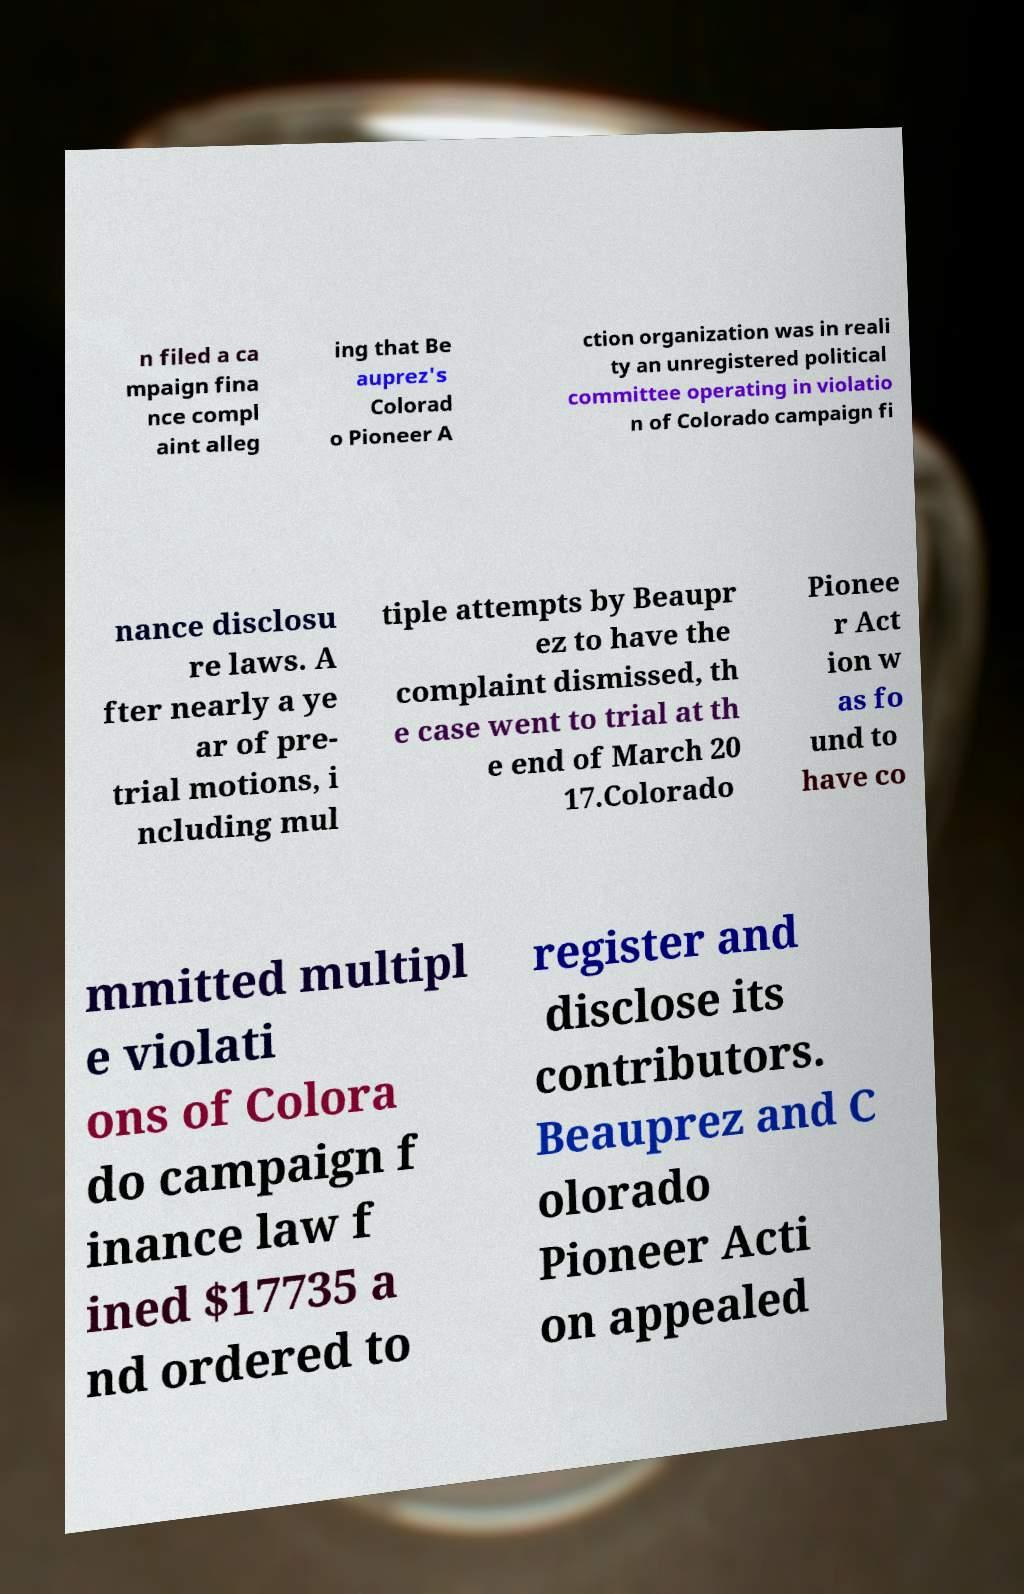Can you read and provide the text displayed in the image?This photo seems to have some interesting text. Can you extract and type it out for me? n filed a ca mpaign fina nce compl aint alleg ing that Be auprez's Colorad o Pioneer A ction organization was in reali ty an unregistered political committee operating in violatio n of Colorado campaign fi nance disclosu re laws. A fter nearly a ye ar of pre- trial motions, i ncluding mul tiple attempts by Beaupr ez to have the complaint dismissed, th e case went to trial at th e end of March 20 17.Colorado Pionee r Act ion w as fo und to have co mmitted multipl e violati ons of Colora do campaign f inance law f ined $17735 a nd ordered to register and disclose its contributors. Beauprez and C olorado Pioneer Acti on appealed 